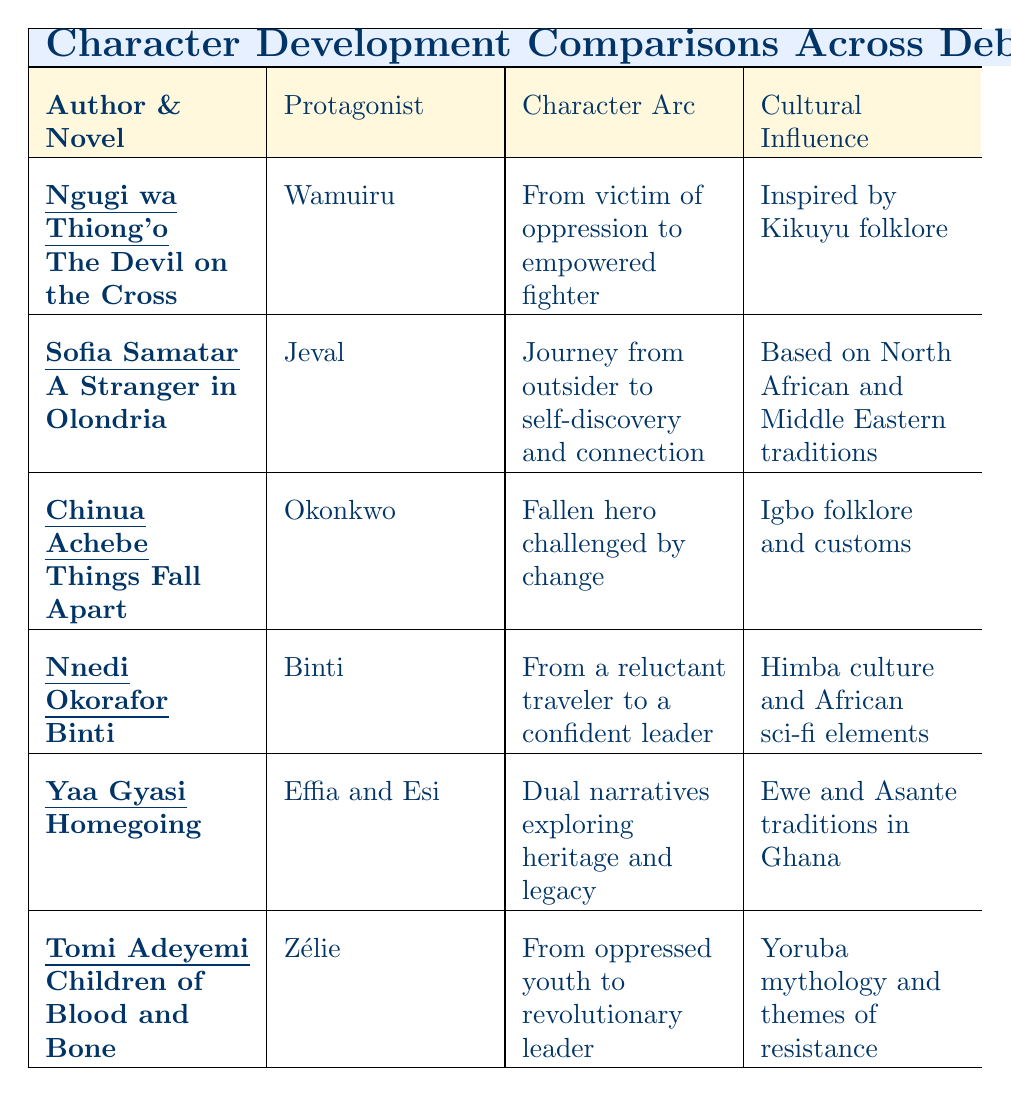What is the protagonist's name in Ngugi wa Thiong'o's novel? The table lists the protagonist associated with each author and novel. For Ngugi wa Thiong'o's "The Devil on the Cross," the protagonist is noted as Wamuiru.
Answer: Wamuiru Which character undergoes a journey from outsider to self-discovery? By reviewing the table, Sofia Samatar's novel "A Stranger in Olondria" features the protagonist Jeval, who has the specified character arc from outsider to self-discovery.
Answer: Jeval What cultural influence does Tomi Adeyemi draw upon in "Children of Blood and Bone"? The table indicates that Tomi Adeyemi's novel draws cultural influence from Yoruba mythology and themes of resistance, as stated in the Cultural Influence column.
Answer: Yoruba mythology How many characters have a character arc involving empowerment? Analyzing the Character Arc column, both Wamuiru from "The Devil on the Cross" and Zélie from "Children of Blood and Bone" contain themes of empowerment, making a total of two characters.
Answer: 2 Is the character Okonkwo from "Things Fall Apart" portrayed as a hero or a villain? The Character Arc for Okonkwo shows that he is described as a fallen hero challenged by change, indicating a complex character rather than a straightforward villain. Therefore, the answer is no.
Answer: No Which two novels explore themes of heritage and legacy? Referring to the Character Arc column, "Homegoing" by Yaa Gyasi explores dual narratives on heritage and legacy, while no other novel in this table shares that specific theme. Hence, the answer is only "Homegoing."
Answer: Homegoing Which novel uses symbolism as a character development technique? By checking the Development Techniques column, both "The Devil on the Cross" and "Children of Blood and Bone" utilize symbolism. Thus, we gather that at least two novels employ this technique.
Answer: 2 What is the main character arc of Binti from "Binti"? The table specifically states that Binti's character arc is from a reluctant traveler to a confident leader, which details the progression of her character throughout the story.
Answer: From a reluctant traveler to a confident leader Do multiple characters from these novels share a common cultural influence? A review of the Cultural Influence column reveals distinct cultural elements for each novel, indicating that there is no overlap in cultural influences among the characters presented in the table. Therefore, the answer is no.
Answer: No What does the character development technique of "intergenerational storytelling" imply in the context of Yaa Gyasi's "Homegoing"? The mentioned technique suggests that "Homegoing" utilizes diverse perspectives across generations that contribute to the understanding of characters and their connections to heritage and legacy, enhancing depth in character development.
Answer: Diverse perspectives across generations 